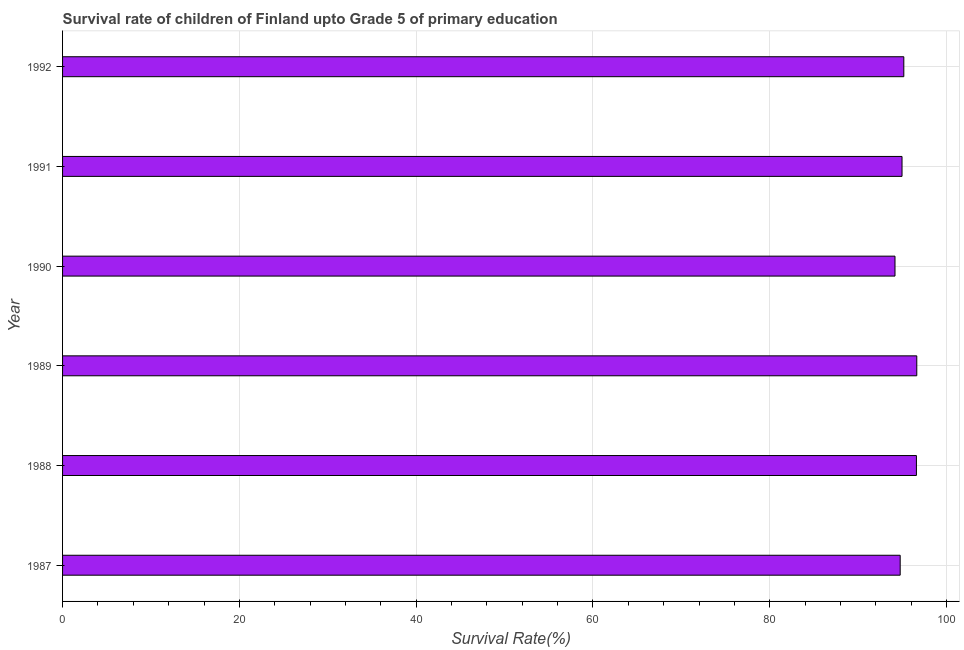Does the graph contain any zero values?
Give a very brief answer. No. Does the graph contain grids?
Provide a short and direct response. Yes. What is the title of the graph?
Offer a very short reply. Survival rate of children of Finland upto Grade 5 of primary education. What is the label or title of the X-axis?
Ensure brevity in your answer.  Survival Rate(%). What is the label or title of the Y-axis?
Your answer should be very brief. Year. What is the survival rate in 1990?
Provide a short and direct response. 94.17. Across all years, what is the maximum survival rate?
Offer a terse response. 96.64. Across all years, what is the minimum survival rate?
Your answer should be compact. 94.17. In which year was the survival rate minimum?
Provide a short and direct response. 1990. What is the sum of the survival rate?
Keep it short and to the point. 572.3. What is the difference between the survival rate in 1989 and 1990?
Provide a short and direct response. 2.46. What is the average survival rate per year?
Provide a succinct answer. 95.38. What is the median survival rate?
Your answer should be very brief. 95.07. What is the ratio of the survival rate in 1987 to that in 1992?
Offer a very short reply. 1. Is the difference between the survival rate in 1989 and 1990 greater than the difference between any two years?
Offer a very short reply. Yes. What is the difference between the highest and the second highest survival rate?
Provide a short and direct response. 0.04. What is the difference between the highest and the lowest survival rate?
Offer a terse response. 2.46. In how many years, is the survival rate greater than the average survival rate taken over all years?
Your answer should be very brief. 2. How many bars are there?
Give a very brief answer. 6. How many years are there in the graph?
Ensure brevity in your answer.  6. What is the difference between two consecutive major ticks on the X-axis?
Your answer should be very brief. 20. What is the Survival Rate(%) in 1987?
Give a very brief answer. 94.76. What is the Survival Rate(%) in 1988?
Ensure brevity in your answer.  96.59. What is the Survival Rate(%) in 1989?
Offer a very short reply. 96.64. What is the Survival Rate(%) of 1990?
Make the answer very short. 94.17. What is the Survival Rate(%) of 1991?
Offer a terse response. 94.97. What is the Survival Rate(%) in 1992?
Keep it short and to the point. 95.17. What is the difference between the Survival Rate(%) in 1987 and 1988?
Offer a very short reply. -1.84. What is the difference between the Survival Rate(%) in 1987 and 1989?
Keep it short and to the point. -1.88. What is the difference between the Survival Rate(%) in 1987 and 1990?
Give a very brief answer. 0.59. What is the difference between the Survival Rate(%) in 1987 and 1991?
Make the answer very short. -0.21. What is the difference between the Survival Rate(%) in 1987 and 1992?
Your answer should be compact. -0.41. What is the difference between the Survival Rate(%) in 1988 and 1989?
Keep it short and to the point. -0.04. What is the difference between the Survival Rate(%) in 1988 and 1990?
Offer a very short reply. 2.42. What is the difference between the Survival Rate(%) in 1988 and 1991?
Offer a terse response. 1.63. What is the difference between the Survival Rate(%) in 1988 and 1992?
Offer a terse response. 1.43. What is the difference between the Survival Rate(%) in 1989 and 1990?
Keep it short and to the point. 2.46. What is the difference between the Survival Rate(%) in 1989 and 1991?
Your answer should be compact. 1.67. What is the difference between the Survival Rate(%) in 1989 and 1992?
Keep it short and to the point. 1.47. What is the difference between the Survival Rate(%) in 1990 and 1991?
Offer a terse response. -0.79. What is the difference between the Survival Rate(%) in 1990 and 1992?
Provide a short and direct response. -1. What is the difference between the Survival Rate(%) in 1991 and 1992?
Offer a terse response. -0.2. What is the ratio of the Survival Rate(%) in 1987 to that in 1989?
Offer a terse response. 0.98. What is the ratio of the Survival Rate(%) in 1987 to that in 1990?
Your answer should be compact. 1.01. What is the ratio of the Survival Rate(%) in 1988 to that in 1989?
Give a very brief answer. 1. What is the ratio of the Survival Rate(%) in 1988 to that in 1990?
Offer a very short reply. 1.03. What is the ratio of the Survival Rate(%) in 1988 to that in 1991?
Your answer should be compact. 1.02. What is the ratio of the Survival Rate(%) in 1988 to that in 1992?
Keep it short and to the point. 1.01. What is the ratio of the Survival Rate(%) in 1989 to that in 1991?
Provide a succinct answer. 1.02. 